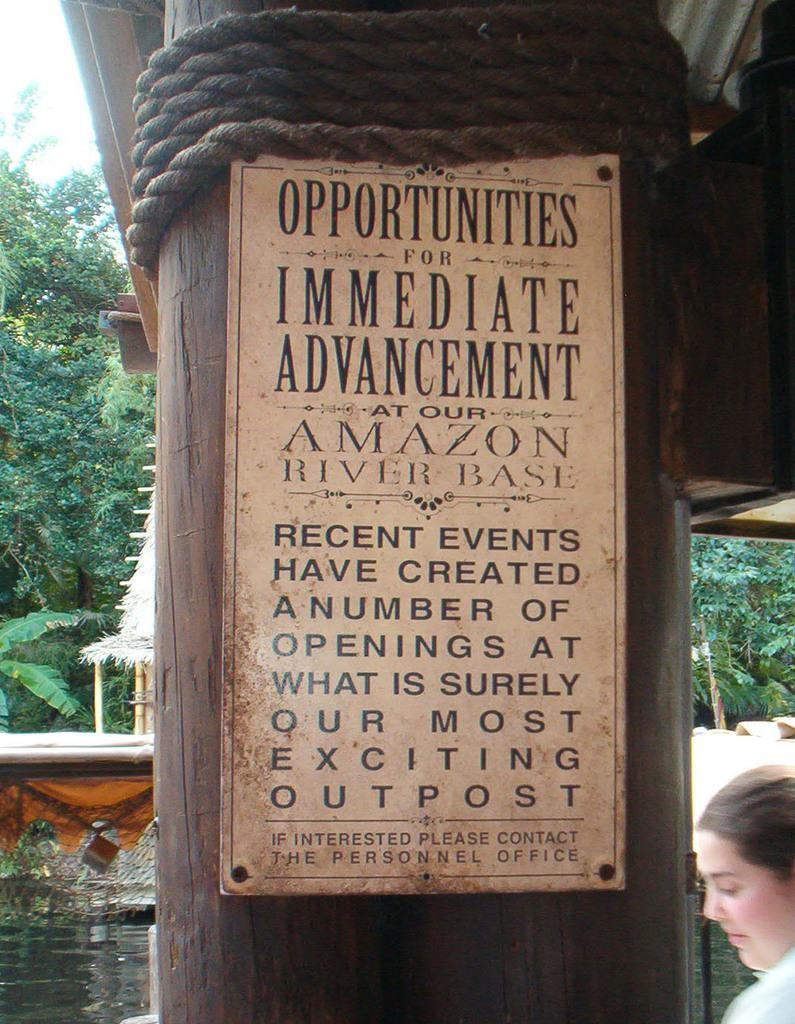Please provide a concise description of this image. Here I can see a pillar to which a board is attached. On the board I can see some text. At the top of it and there is rope. In the bottom right there is a person looking at the downwards. In the bottom left I can see the water. In the background there is a hut and many trees. 